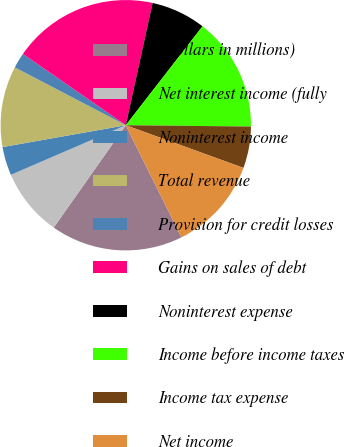Convert chart. <chart><loc_0><loc_0><loc_500><loc_500><pie_chart><fcel>(Dollars in millions)<fcel>Net interest income (fully<fcel>Noninterest income<fcel>Total revenue<fcel>Provision for credit losses<fcel>Gains on sales of debt<fcel>Noninterest expense<fcel>Income before income taxes<fcel>Income tax expense<fcel>Net income<nl><fcel>17.1%<fcel>8.75%<fcel>3.69%<fcel>10.44%<fcel>2.0%<fcel>18.79%<fcel>7.06%<fcel>14.67%<fcel>5.37%<fcel>12.13%<nl></chart> 